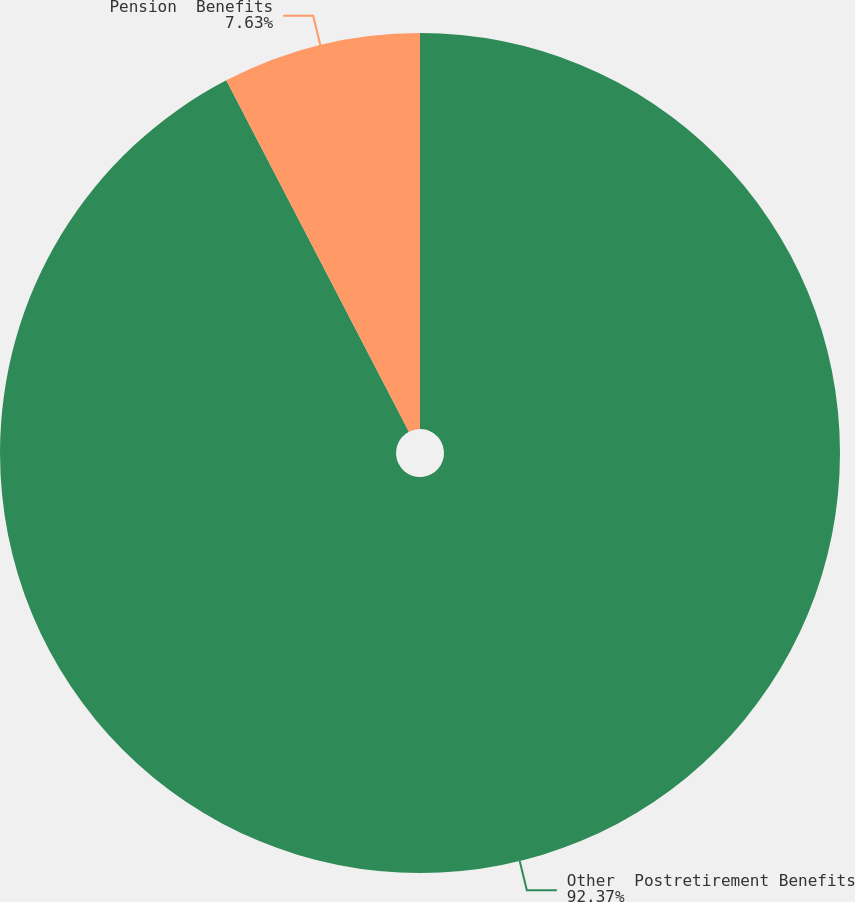Convert chart. <chart><loc_0><loc_0><loc_500><loc_500><pie_chart><fcel>Other  Postretirement Benefits<fcel>Pension  Benefits<nl><fcel>92.37%<fcel>7.63%<nl></chart> 